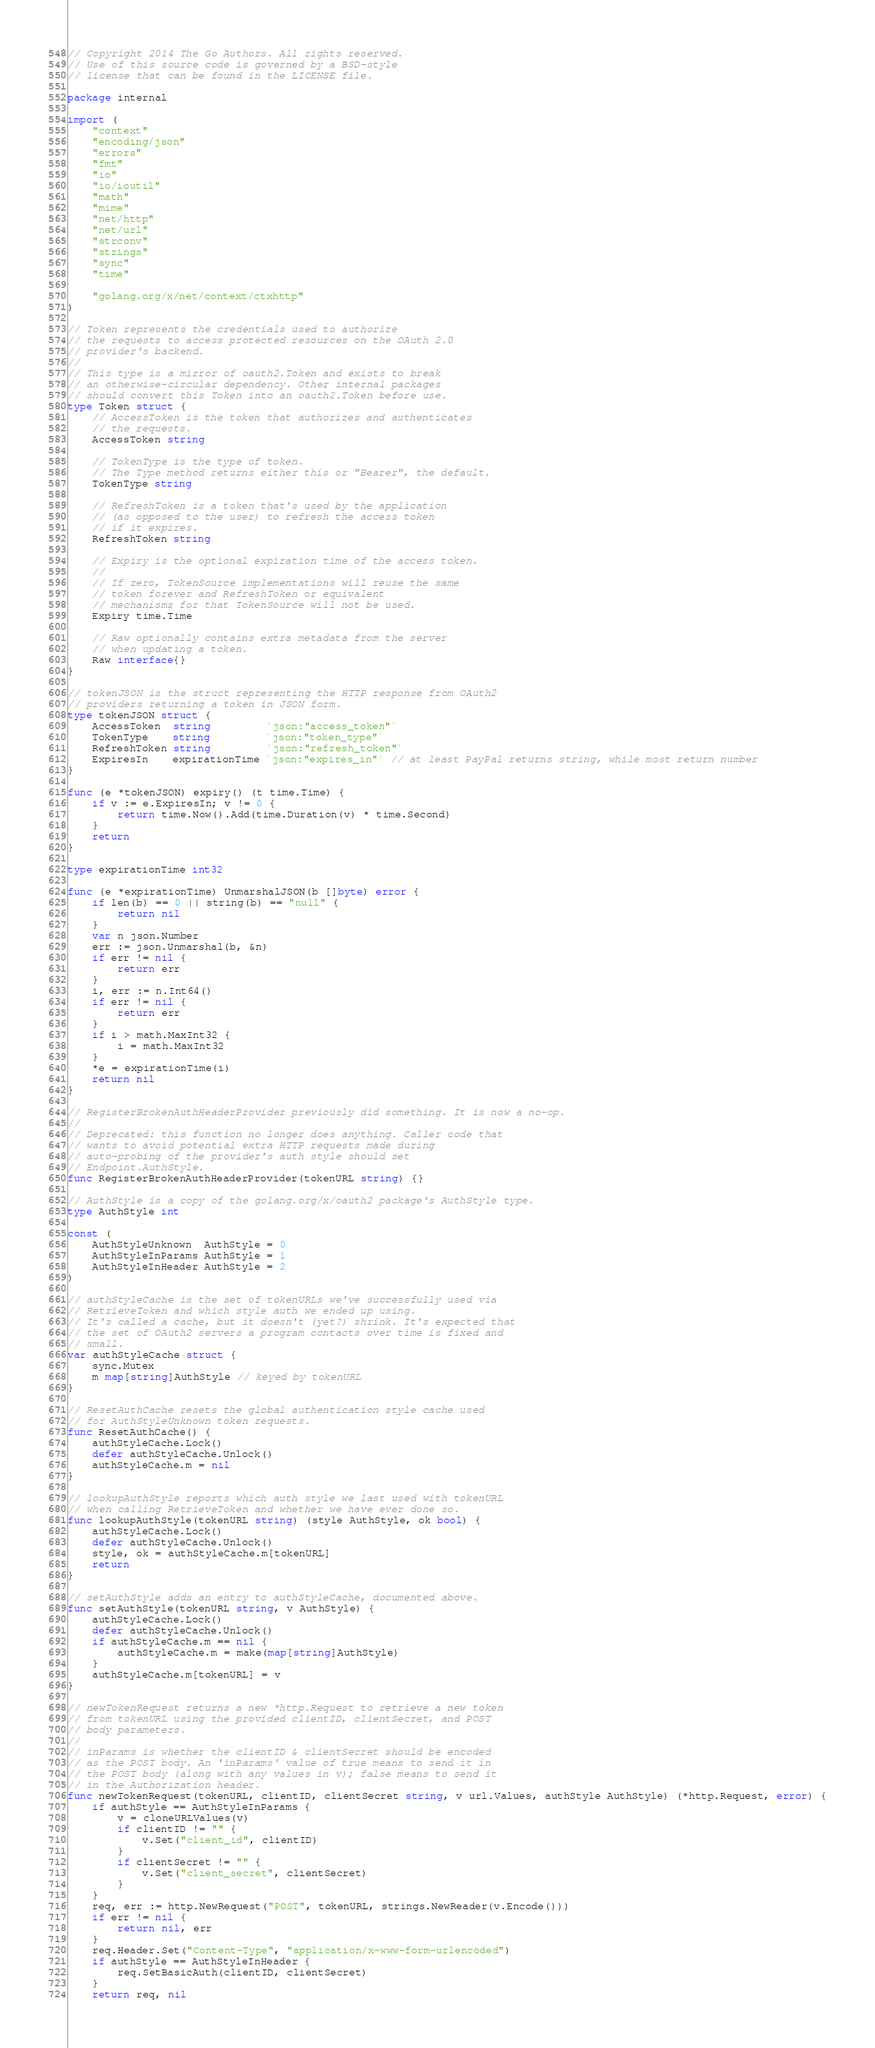<code> <loc_0><loc_0><loc_500><loc_500><_Go_>// Copyright 2014 The Go Authors. All rights reserved.
// Use of this source code is governed by a BSD-style
// license that can be found in the LICENSE file.

package internal

import (
	"context"
	"encoding/json"
	"errors"
	"fmt"
	"io"
	"io/ioutil"
	"math"
	"mime"
	"net/http"
	"net/url"
	"strconv"
	"strings"
	"sync"
	"time"

	"golang.org/x/net/context/ctxhttp"
)

// Token represents the credentials used to authorize
// the requests to access protected resources on the OAuth 2.0
// provider's backend.
//
// This type is a mirror of oauth2.Token and exists to break
// an otherwise-circular dependency. Other internal packages
// should convert this Token into an oauth2.Token before use.
type Token struct {
	// AccessToken is the token that authorizes and authenticates
	// the requests.
	AccessToken string

	// TokenType is the type of token.
	// The Type method returns either this or "Bearer", the default.
	TokenType string

	// RefreshToken is a token that's used by the application
	// (as opposed to the user) to refresh the access token
	// if it expires.
	RefreshToken string

	// Expiry is the optional expiration time of the access token.
	//
	// If zero, TokenSource implementations will reuse the same
	// token forever and RefreshToken or equivalent
	// mechanisms for that TokenSource will not be used.
	Expiry time.Time

	// Raw optionally contains extra metadata from the server
	// when updating a token.
	Raw interface{}
}

// tokenJSON is the struct representing the HTTP response from OAuth2
// providers returning a token in JSON form.
type tokenJSON struct {
	AccessToken  string         `json:"access_token"`
	TokenType    string         `json:"token_type"`
	RefreshToken string         `json:"refresh_token"`
	ExpiresIn    expirationTime `json:"expires_in"` // at least PayPal returns string, while most return number
}

func (e *tokenJSON) expiry() (t time.Time) {
	if v := e.ExpiresIn; v != 0 {
		return time.Now().Add(time.Duration(v) * time.Second)
	}
	return
}

type expirationTime int32

func (e *expirationTime) UnmarshalJSON(b []byte) error {
	if len(b) == 0 || string(b) == "null" {
		return nil
	}
	var n json.Number
	err := json.Unmarshal(b, &n)
	if err != nil {
		return err
	}
	i, err := n.Int64()
	if err != nil {
		return err
	}
	if i > math.MaxInt32 {
		i = math.MaxInt32
	}
	*e = expirationTime(i)
	return nil
}

// RegisterBrokenAuthHeaderProvider previously did something. It is now a no-op.
//
// Deprecated: this function no longer does anything. Caller code that
// wants to avoid potential extra HTTP requests made during
// auto-probing of the provider's auth style should set
// Endpoint.AuthStyle.
func RegisterBrokenAuthHeaderProvider(tokenURL string) {}

// AuthStyle is a copy of the golang.org/x/oauth2 package's AuthStyle type.
type AuthStyle int

const (
	AuthStyleUnknown  AuthStyle = 0
	AuthStyleInParams AuthStyle = 1
	AuthStyleInHeader AuthStyle = 2
)

// authStyleCache is the set of tokenURLs we've successfully used via
// RetrieveToken and which style auth we ended up using.
// It's called a cache, but it doesn't (yet?) shrink. It's expected that
// the set of OAuth2 servers a program contacts over time is fixed and
// small.
var authStyleCache struct {
	sync.Mutex
	m map[string]AuthStyle // keyed by tokenURL
}

// ResetAuthCache resets the global authentication style cache used
// for AuthStyleUnknown token requests.
func ResetAuthCache() {
	authStyleCache.Lock()
	defer authStyleCache.Unlock()
	authStyleCache.m = nil
}

// lookupAuthStyle reports which auth style we last used with tokenURL
// when calling RetrieveToken and whether we have ever done so.
func lookupAuthStyle(tokenURL string) (style AuthStyle, ok bool) {
	authStyleCache.Lock()
	defer authStyleCache.Unlock()
	style, ok = authStyleCache.m[tokenURL]
	return
}

// setAuthStyle adds an entry to authStyleCache, documented above.
func setAuthStyle(tokenURL string, v AuthStyle) {
	authStyleCache.Lock()
	defer authStyleCache.Unlock()
	if authStyleCache.m == nil {
		authStyleCache.m = make(map[string]AuthStyle)
	}
	authStyleCache.m[tokenURL] = v
}

// newTokenRequest returns a new *http.Request to retrieve a new token
// from tokenURL using the provided clientID, clientSecret, and POST
// body parameters.
//
// inParams is whether the clientID & clientSecret should be encoded
// as the POST body. An 'inParams' value of true means to send it in
// the POST body (along with any values in v); false means to send it
// in the Authorization header.
func newTokenRequest(tokenURL, clientID, clientSecret string, v url.Values, authStyle AuthStyle) (*http.Request, error) {
	if authStyle == AuthStyleInParams {
		v = cloneURLValues(v)
		if clientID != "" {
			v.Set("client_id", clientID)
		}
		if clientSecret != "" {
			v.Set("client_secret", clientSecret)
		}
	}
	req, err := http.NewRequest("POST", tokenURL, strings.NewReader(v.Encode()))
	if err != nil {
		return nil, err
	}
	req.Header.Set("Content-Type", "application/x-www-form-urlencoded")
	if authStyle == AuthStyleInHeader {
		req.SetBasicAuth(clientID, clientSecret)
	}
	return req, nil</code> 